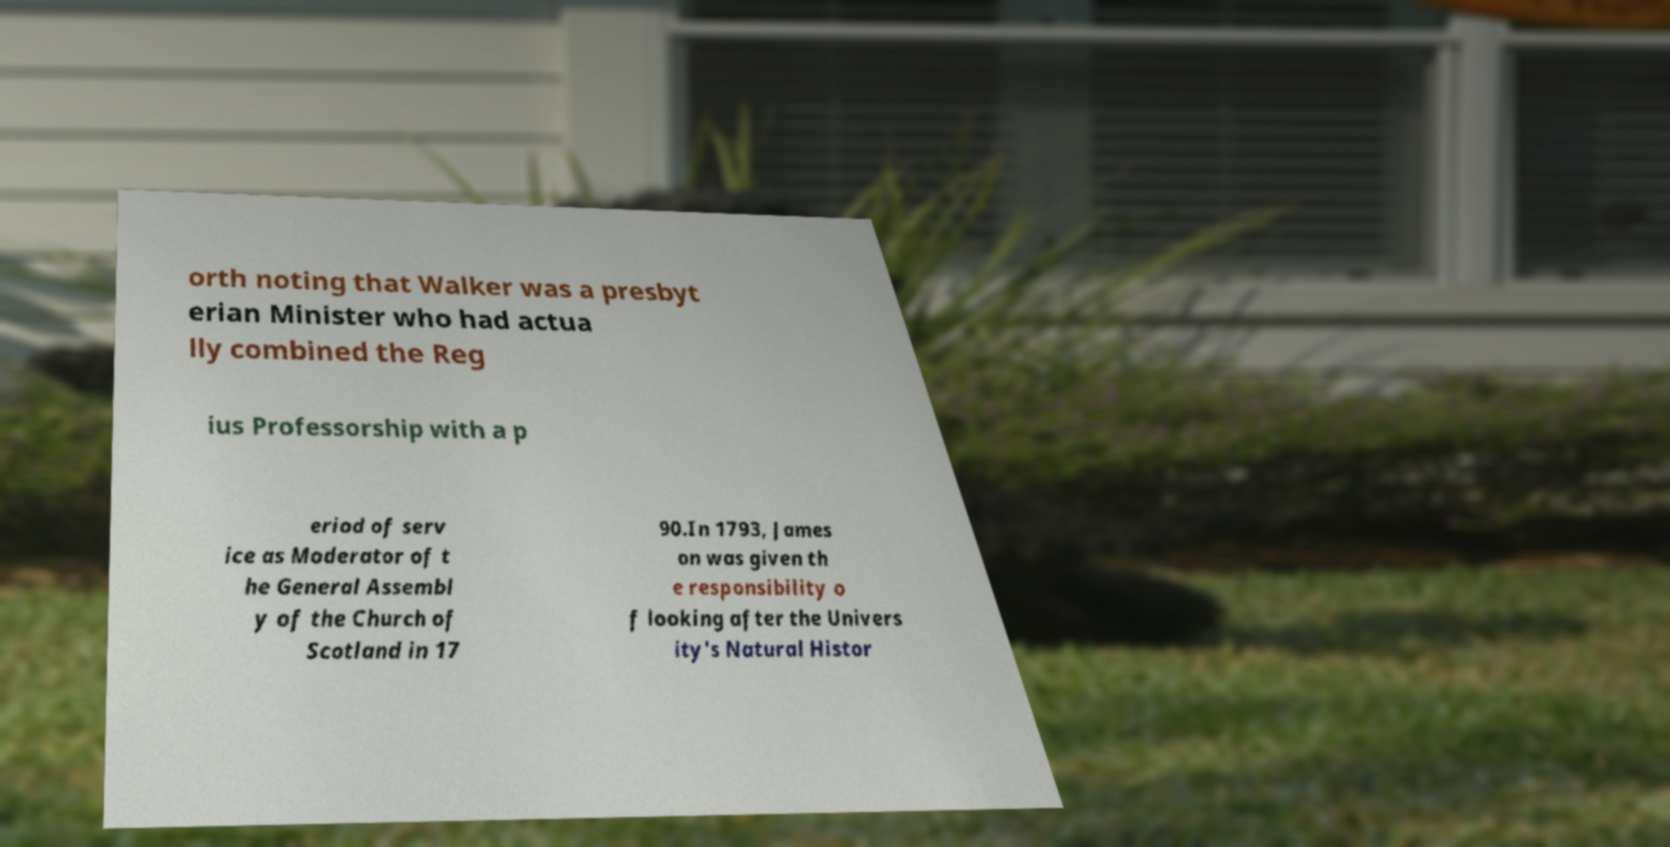What messages or text are displayed in this image? I need them in a readable, typed format. orth noting that Walker was a presbyt erian Minister who had actua lly combined the Reg ius Professorship with a p eriod of serv ice as Moderator of t he General Assembl y of the Church of Scotland in 17 90.In 1793, James on was given th e responsibility o f looking after the Univers ity's Natural Histor 